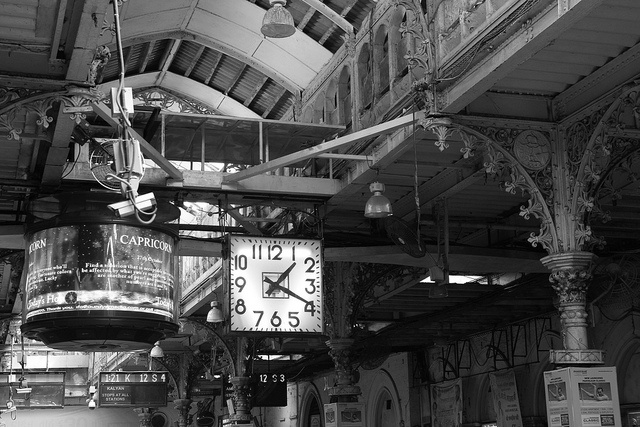Describe the objects in this image and their specific colors. I can see a clock in gray, white, darkgray, and black tones in this image. 